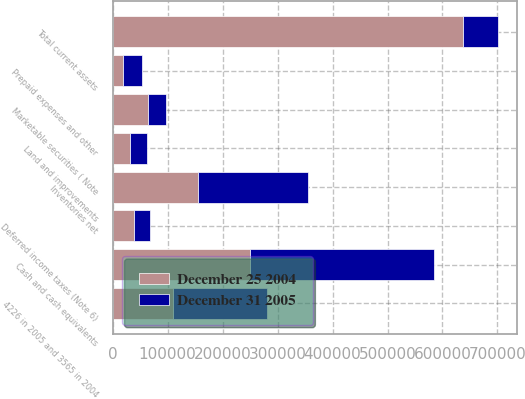<chart> <loc_0><loc_0><loc_500><loc_500><stacked_bar_chart><ecel><fcel>Cash and cash equivalents<fcel>Marketable securities ( Note<fcel>4226 in 2005 and 3565 in 2004<fcel>Inventories net<fcel>Deferred income taxes (Note 6)<fcel>Prepaid expenses and other<fcel>Total current assets<fcel>Land and improvements<nl><fcel>December 31 2005<fcel>334352<fcel>32050<fcel>170997<fcel>199841<fcel>29615<fcel>34312<fcel>64367<fcel>31075<nl><fcel>December 25 2004<fcel>249909<fcel>64367<fcel>110119<fcel>154980<fcel>38527<fcel>19069<fcel>636971<fcel>30931<nl></chart> 